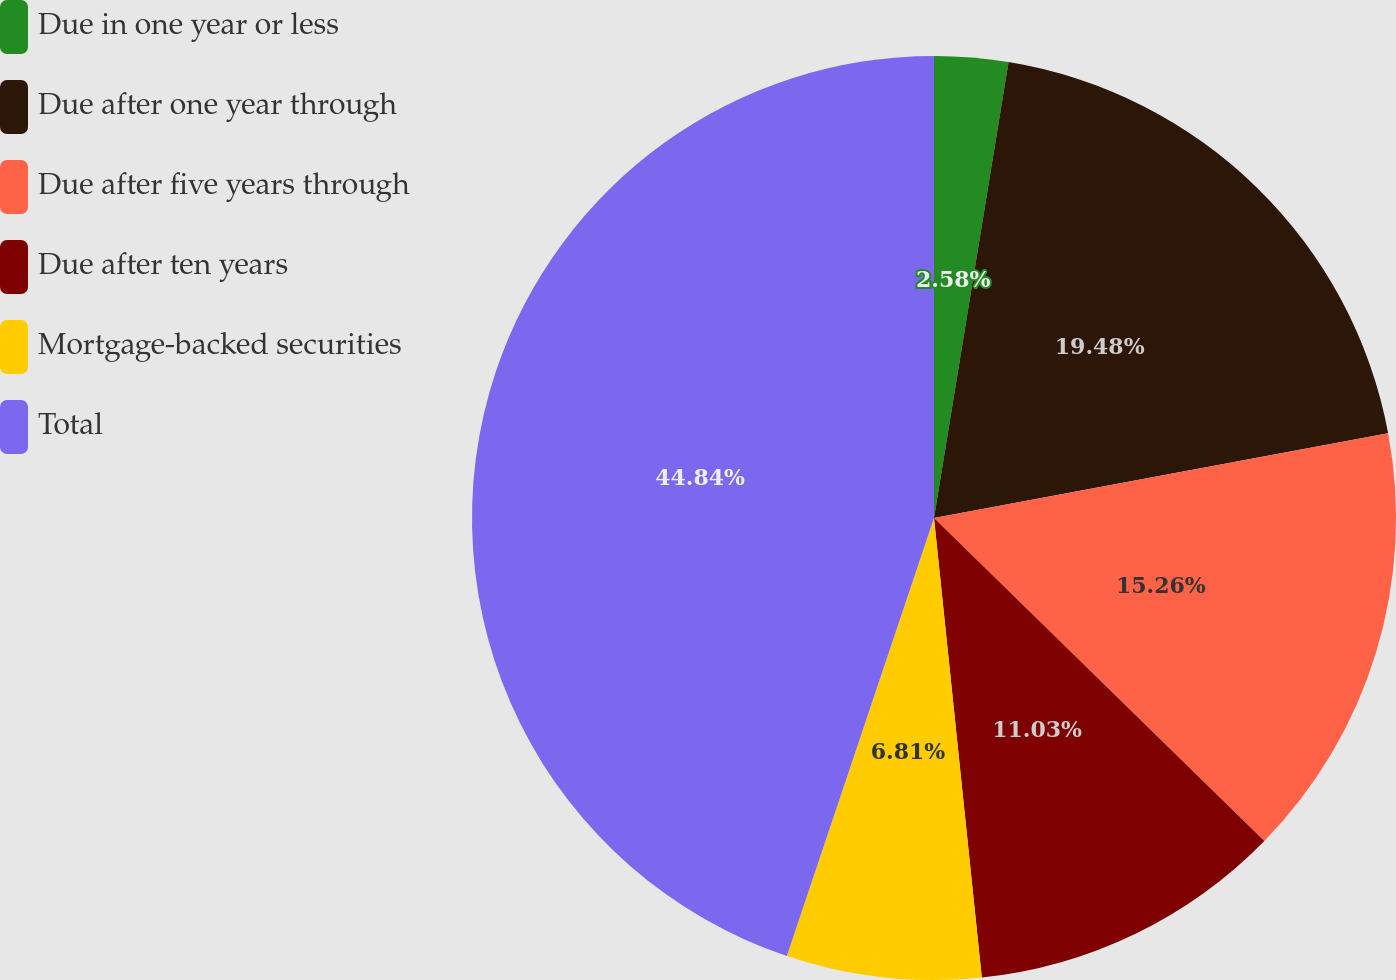<chart> <loc_0><loc_0><loc_500><loc_500><pie_chart><fcel>Due in one year or less<fcel>Due after one year through<fcel>Due after five years through<fcel>Due after ten years<fcel>Mortgage-backed securities<fcel>Total<nl><fcel>2.58%<fcel>19.48%<fcel>15.26%<fcel>11.03%<fcel>6.81%<fcel>44.84%<nl></chart> 